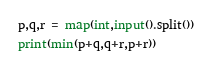<code> <loc_0><loc_0><loc_500><loc_500><_Python_>p,q,r = map(int,input().split())
print(min(p+q,q+r,p+r))</code> 